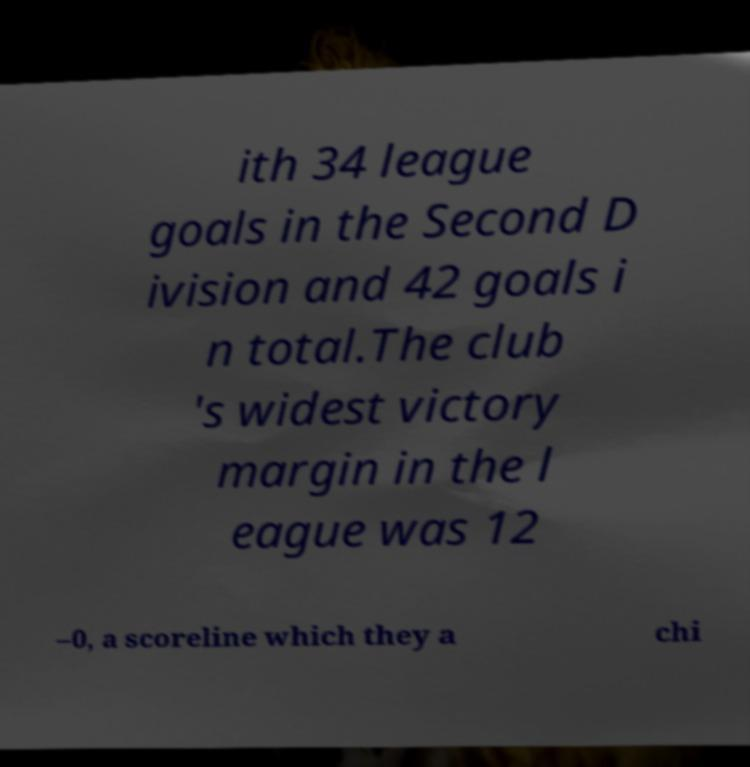Could you extract and type out the text from this image? ith 34 league goals in the Second D ivision and 42 goals i n total.The club 's widest victory margin in the l eague was 12 –0, a scoreline which they a chi 